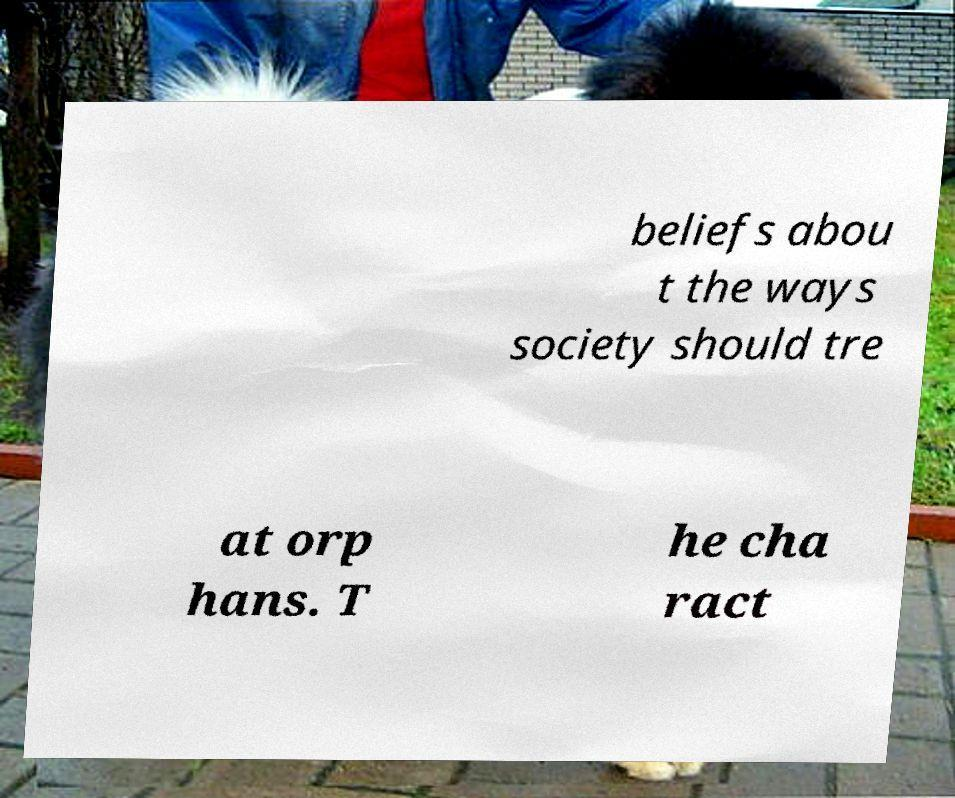There's text embedded in this image that I need extracted. Can you transcribe it verbatim? beliefs abou t the ways society should tre at orp hans. T he cha ract 